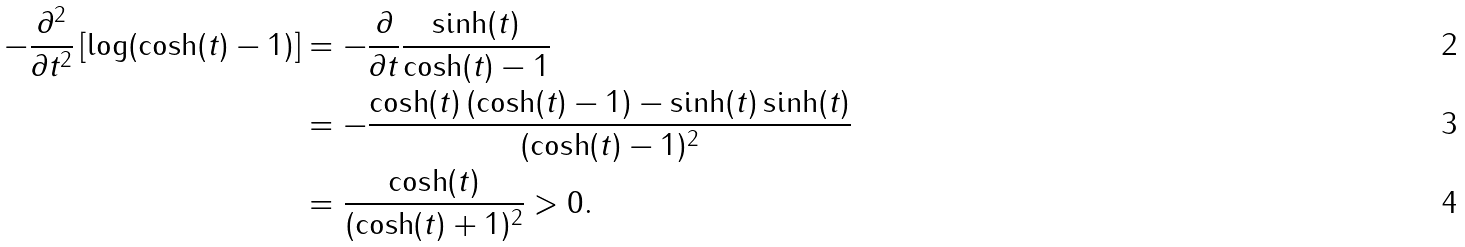Convert formula to latex. <formula><loc_0><loc_0><loc_500><loc_500>- \frac { \partial ^ { 2 } } { \partial t ^ { 2 } } \left [ \log ( \cosh ( t ) - 1 ) \right ] & = - \frac { \partial } { \partial t } \frac { \sinh ( t ) } { \cosh ( t ) - 1 } \\ & = - \frac { \cosh ( t ) \, ( \cosh ( t ) - 1 ) - \sinh ( t ) \sinh ( t ) } { ( \cosh ( t ) - 1 ) ^ { 2 } } \\ & = \frac { \cosh ( t ) } { ( \cosh ( t ) + 1 ) ^ { 2 } } > 0 .</formula> 